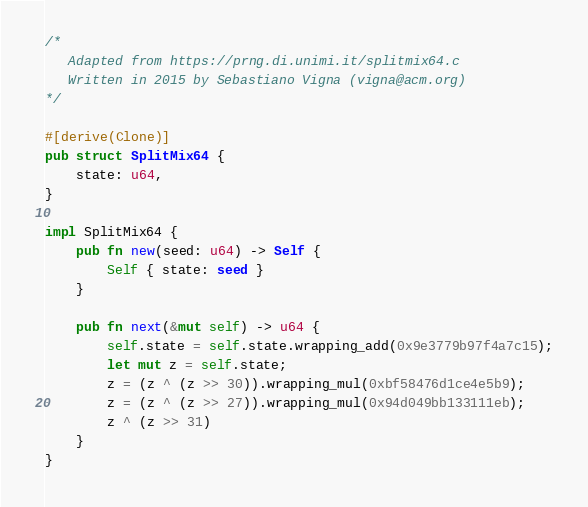<code> <loc_0><loc_0><loc_500><loc_500><_Rust_>/*
   Adapted from https://prng.di.unimi.it/splitmix64.c
   Written in 2015 by Sebastiano Vigna (vigna@acm.org)
*/

#[derive(Clone)]
pub struct SplitMix64 {
    state: u64,
}

impl SplitMix64 {
    pub fn new(seed: u64) -> Self {
        Self { state: seed }
    }

    pub fn next(&mut self) -> u64 {
        self.state = self.state.wrapping_add(0x9e3779b97f4a7c15);
        let mut z = self.state;
        z = (z ^ (z >> 30)).wrapping_mul(0xbf58476d1ce4e5b9);
        z = (z ^ (z >> 27)).wrapping_mul(0x94d049bb133111eb);
        z ^ (z >> 31)
    }
}
</code> 